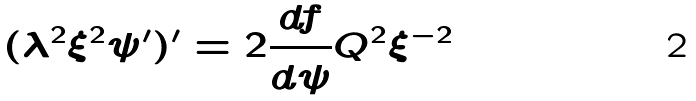Convert formula to latex. <formula><loc_0><loc_0><loc_500><loc_500>( \lambda ^ { 2 } \xi ^ { 2 } \psi ^ { \prime } ) ^ { \prime } = 2 \frac { d f } { d \psi } Q ^ { 2 } \xi ^ { - 2 }</formula> 